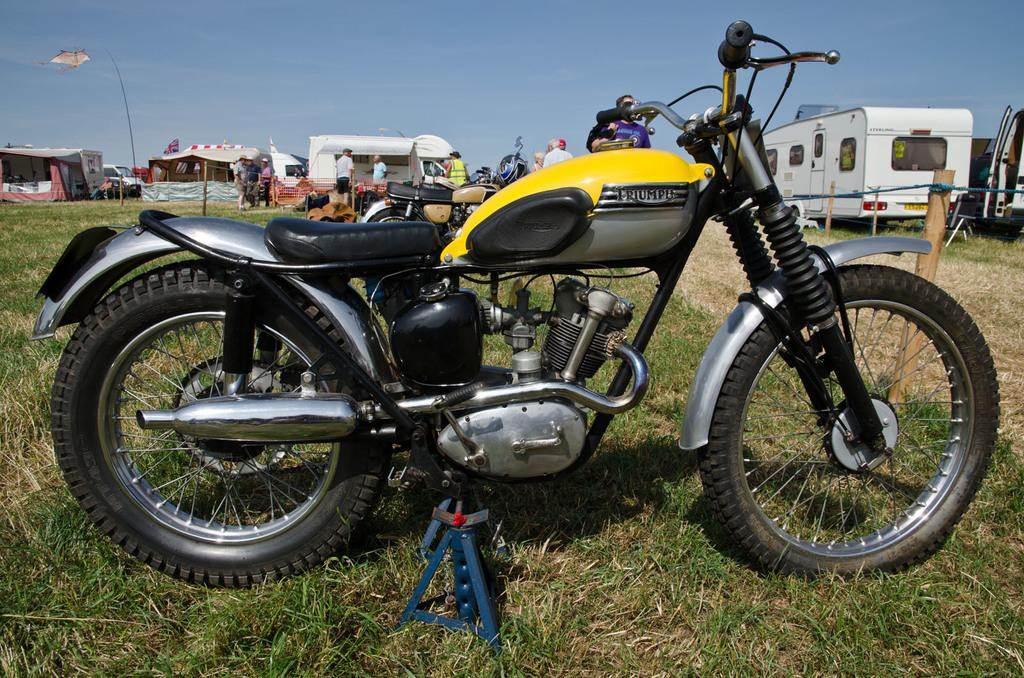What types of objects are in the image? There are vehicles and a group of people in the image. What can be seen in the background of the image? There are tents and grass in the background of the image. What type of sock is being used to rake the grain in the image? There is no sock, rake, or grain present in the image. 